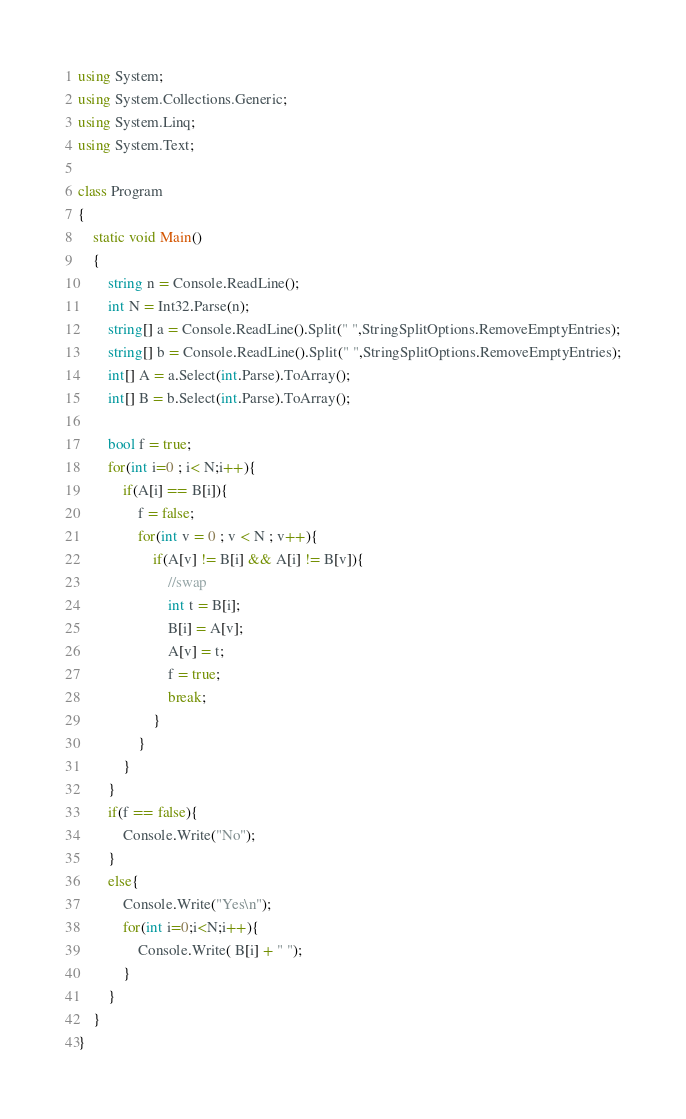<code> <loc_0><loc_0><loc_500><loc_500><_C#_>using System;
using System.Collections.Generic;
using System.Linq;
using System.Text;

class Program
{
    static void Main()
    {
        string n = Console.ReadLine();
        int N = Int32.Parse(n);
        string[] a = Console.ReadLine().Split(" ",StringSplitOptions.RemoveEmptyEntries);
        string[] b = Console.ReadLine().Split(" ",StringSplitOptions.RemoveEmptyEntries);
        int[] A = a.Select(int.Parse).ToArray();
        int[] B = b.Select(int.Parse).ToArray();
        
        bool f = true;
        for(int i=0 ; i< N;i++){
            if(A[i] == B[i]){
                f = false;
                for(int v = 0 ; v < N ; v++){
                    if(A[v] != B[i] && A[i] != B[v]){
                        //swap
                        int t = B[i];
                        B[i] = A[v];
                        A[v] = t;
                        f = true;
                        break; 
                    }
                }
            }
        }
        if(f == false){
            Console.Write("No");
        }
        else{
            Console.Write("Yes\n");
            for(int i=0;i<N;i++){
                Console.Write( B[i] + " ");
            }
        }
    }
}</code> 